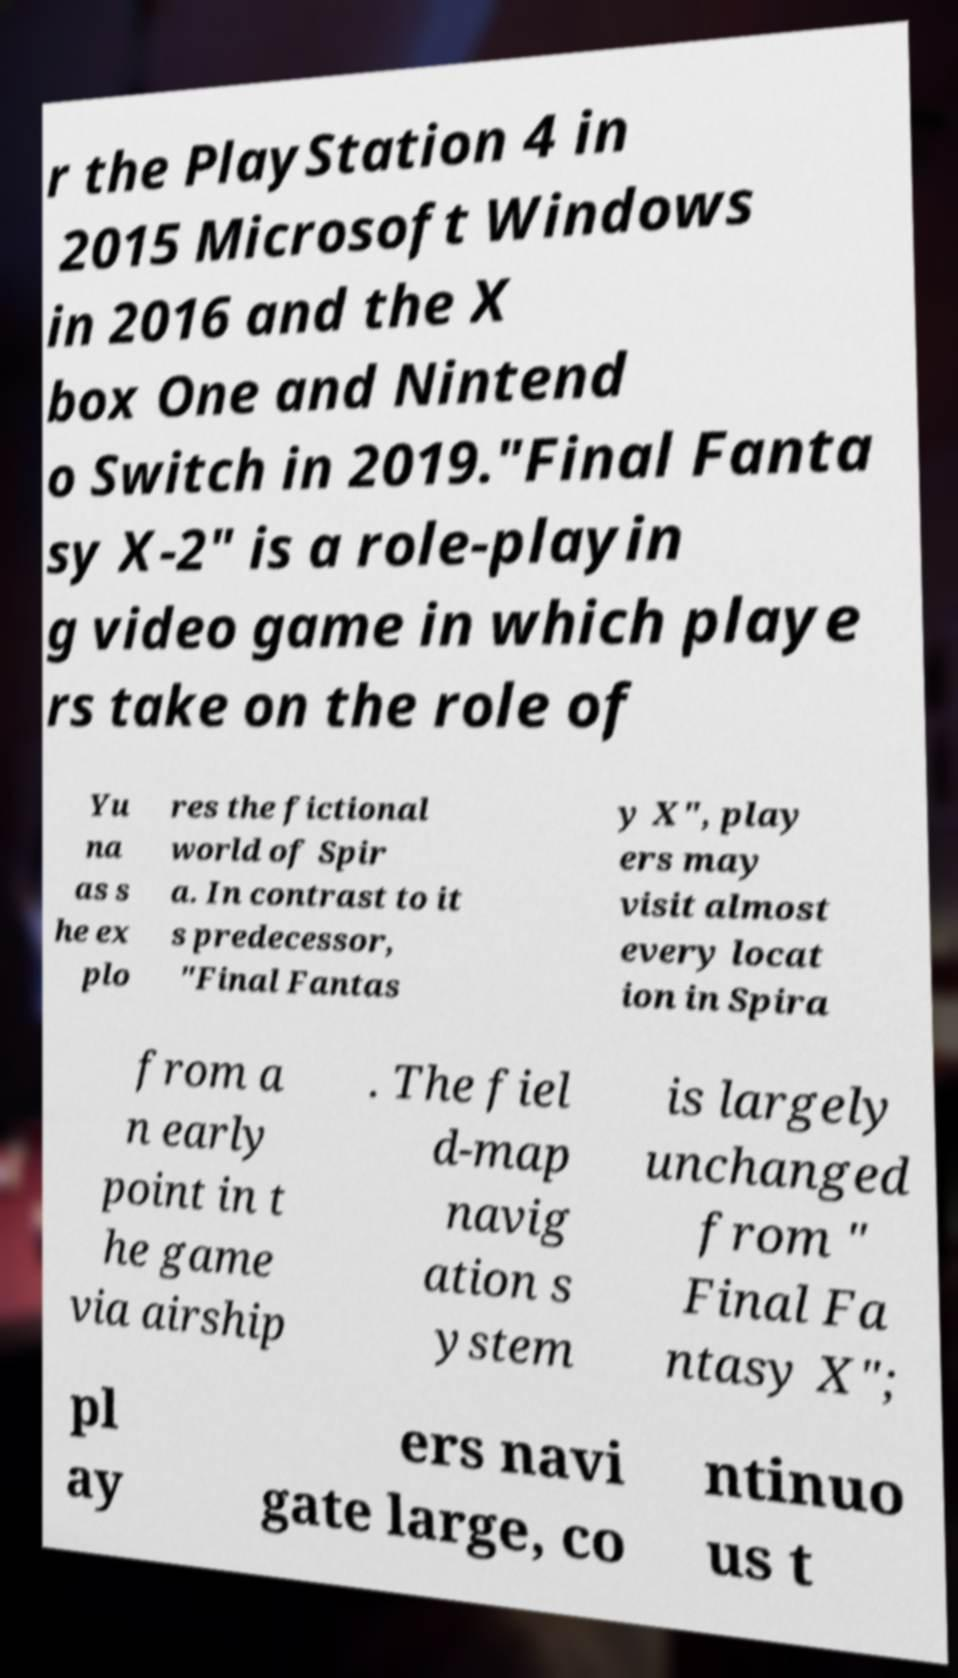Please identify and transcribe the text found in this image. r the PlayStation 4 in 2015 Microsoft Windows in 2016 and the X box One and Nintend o Switch in 2019."Final Fanta sy X-2" is a role-playin g video game in which playe rs take on the role of Yu na as s he ex plo res the fictional world of Spir a. In contrast to it s predecessor, "Final Fantas y X", play ers may visit almost every locat ion in Spira from a n early point in t he game via airship . The fiel d-map navig ation s ystem is largely unchanged from " Final Fa ntasy X"; pl ay ers navi gate large, co ntinuo us t 